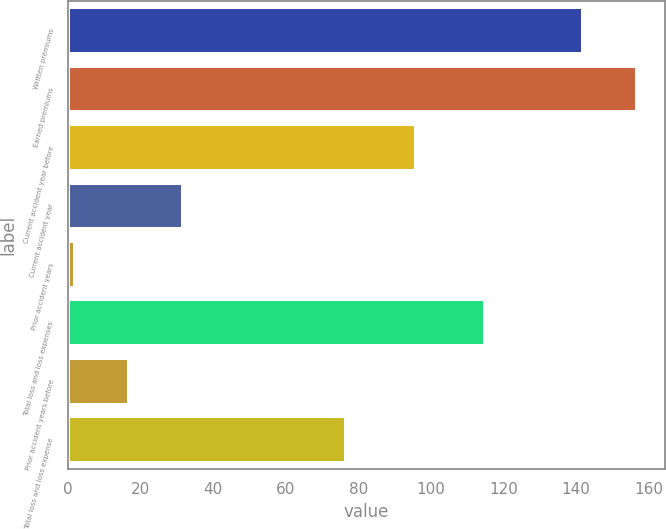<chart> <loc_0><loc_0><loc_500><loc_500><bar_chart><fcel>Written premiums<fcel>Earned premiums<fcel>Current accident year before<fcel>Current accident year<fcel>Prior accident years<fcel>Total loss and loss expenses<fcel>Prior accident years before<fcel>Total loss and loss expense<nl><fcel>142<fcel>156.8<fcel>96<fcel>31.6<fcel>2<fcel>115<fcel>16.8<fcel>76.5<nl></chart> 